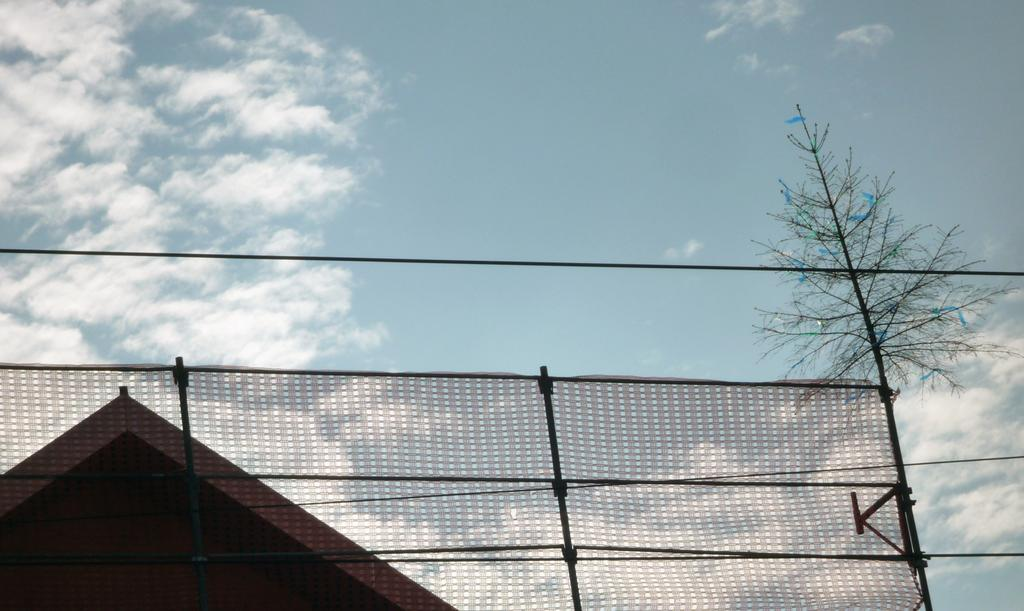What is tied to the rod in the foreground of the image? There is cloth tied to a rod in the foreground of the image. What can be seen in the background of the image? There is a house and a tree in the background of the image. What is visible in the sky in the background of the image? The sky is visible in the background of the image, and there are clouds in the sky. What type of poison is being used to treat the tree in the image? There is no mention of poison or any treatment for the tree in the image. The tree appears to be a natural part of the background. 